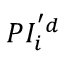Convert formula to latex. <formula><loc_0><loc_0><loc_500><loc_500>P I _ { i } ^ { ^ { \prime } d }</formula> 